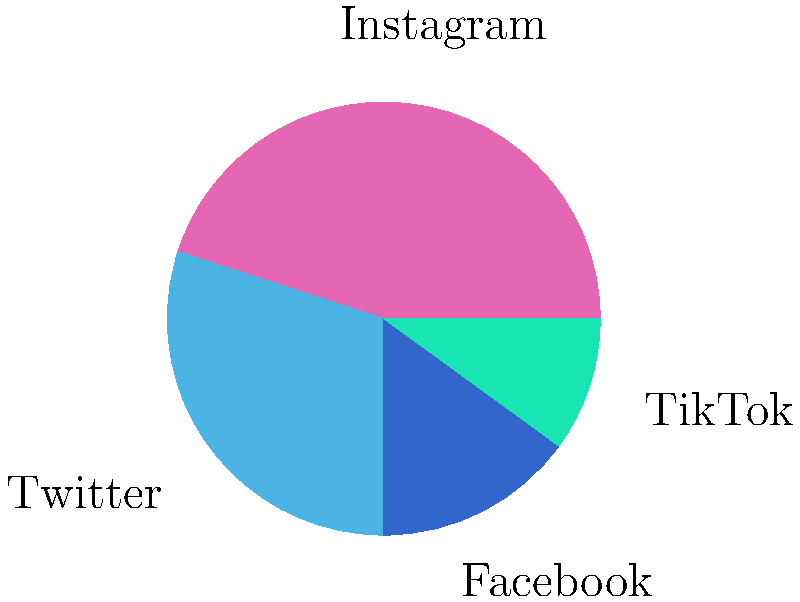Based on the pie chart showing Amelia Crowley's social media follower distribution, which platform has the second-largest percentage of her followers, and what is the difference between the percentages of her followers on Instagram and this platform? To answer this question, we need to follow these steps:

1. Identify the platform with the second-largest percentage of followers:
   - Instagram: 45%
   - Twitter: 30%
   - Facebook: 15%
   - TikTok: 10%
   Twitter has the second-largest percentage at 30%.

2. Calculate the difference between Instagram and Twitter percentages:
   - Instagram percentage: 45%
   - Twitter percentage: 30%
   - Difference: 45% - 30% = 15%

Therefore, Twitter is the platform with the second-largest percentage of Amelia Crowley's followers, and the difference between Instagram and Twitter percentages is 15%.
Answer: Twitter, 15% 